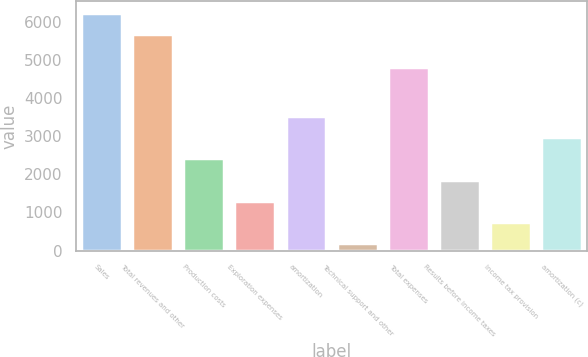Convert chart. <chart><loc_0><loc_0><loc_500><loc_500><bar_chart><fcel>Sales<fcel>Total revenues and other<fcel>Production costs<fcel>Exploration expenses<fcel>amortization<fcel>Technical support and other<fcel>Total expenses<fcel>Results before income taxes<fcel>Income tax provision<fcel>amortization (c)<nl><fcel>6228.1<fcel>5672<fcel>2417.4<fcel>1305.2<fcel>3529.6<fcel>193<fcel>4818<fcel>1861.3<fcel>749.1<fcel>2973.5<nl></chart> 